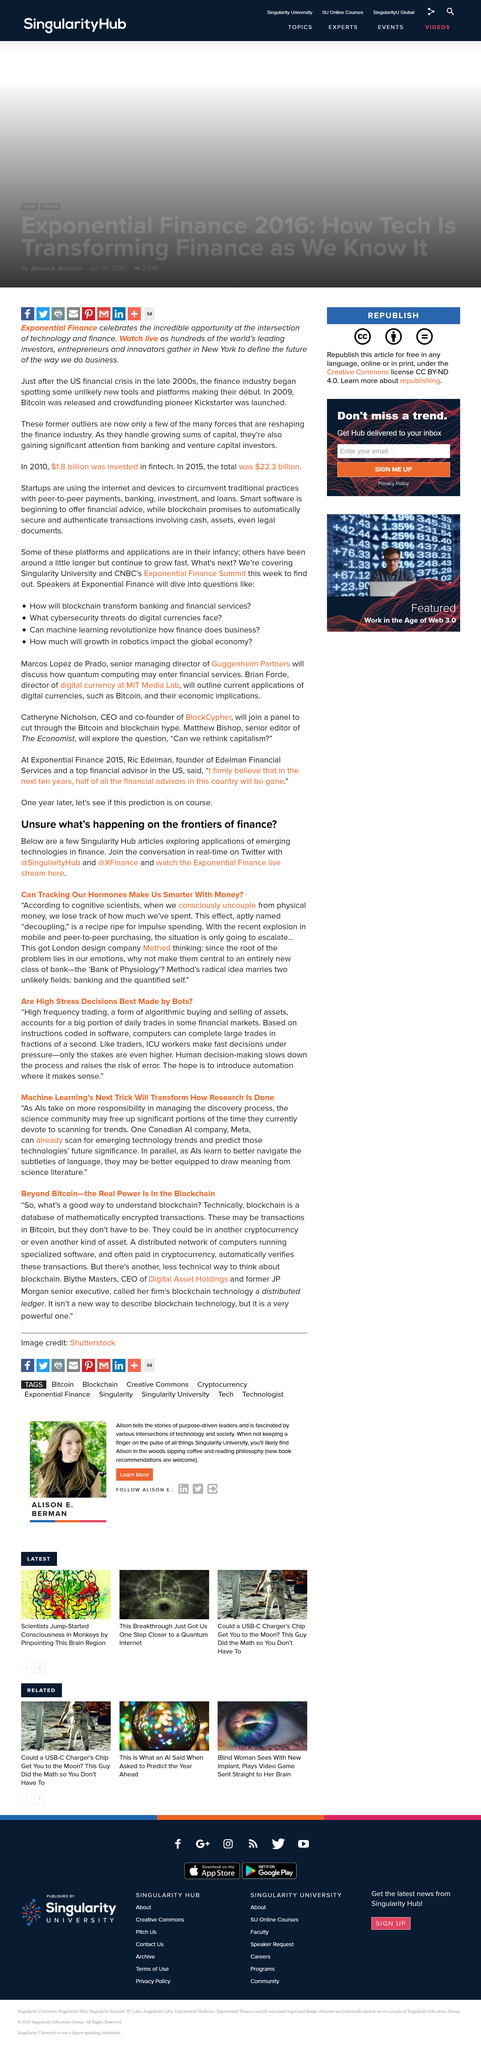Identify some key points in this picture. The location of the design company "Method" is London. It is possible to participate in a real-time conversation on Twitter with the handle @XFinance. The article "Can Tracking Our Hormones Make Us Smarter With Money?" explores the potential applications of emerging technologies in finance. 